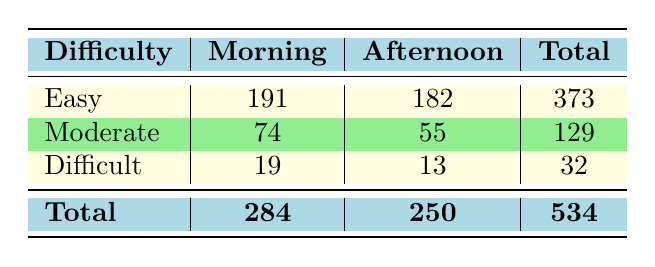What is the total number of hikers on Easy trails in the morning? According to the table, the total number of hikers on Easy trails in the morning is the sum of the hikers on Borrego Palm Canyon Nature Trail, Slot Canyon Trail, The Slot, and Fonts Point Trail: (67 + 38 + 52 + 34) = 191.
Answer: 191 How many more hikers visited Moderate trails in the morning compared to the afternoon? To find the difference, we take the number of hikers on Moderate trails in the morning, which is 74, and subtract the number of hikers in the afternoon, which is 55: 74 - 55 = 19.
Answer: 19 True or False: There were more hikers on Difficult trails in the morning than in the afternoon. From the table, there were 19 hikers on Difficult trails in the morning and 13 in the afternoon. Since 19 > 13, the statement is true.
Answer: True What is the total number of hikers who used the trails in the afternoon? The total number of hikers in the afternoon can be calculated by summing the values from each difficulty category: (182 for Easy + 55 for Moderate + 13 for Difficult) = 250.
Answer: 250 Which difficulty level has the highest total number of hikers overall? By adding the total hikers for each difficulty level: Easy has 373, Moderate has 129, and Difficult has 32. The highest total is for Easy trails with 373 hikers.
Answer: Easy How many hikers used the trails in the morning compared to those in the afternoon? Adding total hikers for the morning gives us (284), and for the afternoon, it is (250). This shows that more hikers used the trails in the morning by a difference of 284 - 250 = 34.
Answer: 34 more in the morning Is the number of hikers on Moderate trails greater than the number of hikers on Difficult trails in both morning and afternoon? In the morning, Moderate trails have 74 hikers compared to 19 on Difficult trails; in the afternoon, Moderate trails have 55 compared to 13 on Difficult trails. Both comparisons show that Moderate trails have more hikers than Difficult trails.
Answer: Yes What’s the average number of hikers across all trails in the morning? The average is calculated by taking the total number of morning hikers (284) and dividing by the total number of difficulty categories (3), leading to 284 / 3 = approximately 94.67.
Answer: Approximately 94.67 